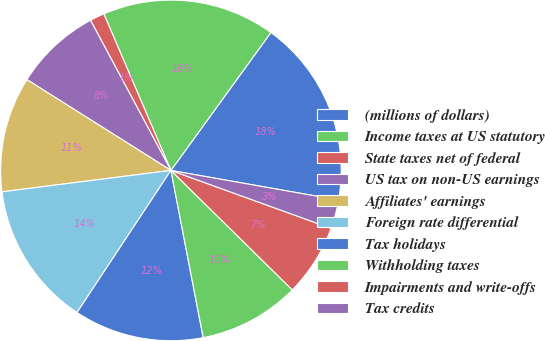Convert chart to OTSL. <chart><loc_0><loc_0><loc_500><loc_500><pie_chart><fcel>(millions of dollars)<fcel>Income taxes at US statutory<fcel>State taxes net of federal<fcel>US tax on non-US earnings<fcel>Affiliates' earnings<fcel>Foreign rate differential<fcel>Tax holidays<fcel>Withholding taxes<fcel>Impairments and write-offs<fcel>Tax credits<nl><fcel>17.8%<fcel>16.43%<fcel>1.38%<fcel>8.22%<fcel>10.96%<fcel>13.7%<fcel>12.33%<fcel>9.59%<fcel>6.85%<fcel>2.74%<nl></chart> 